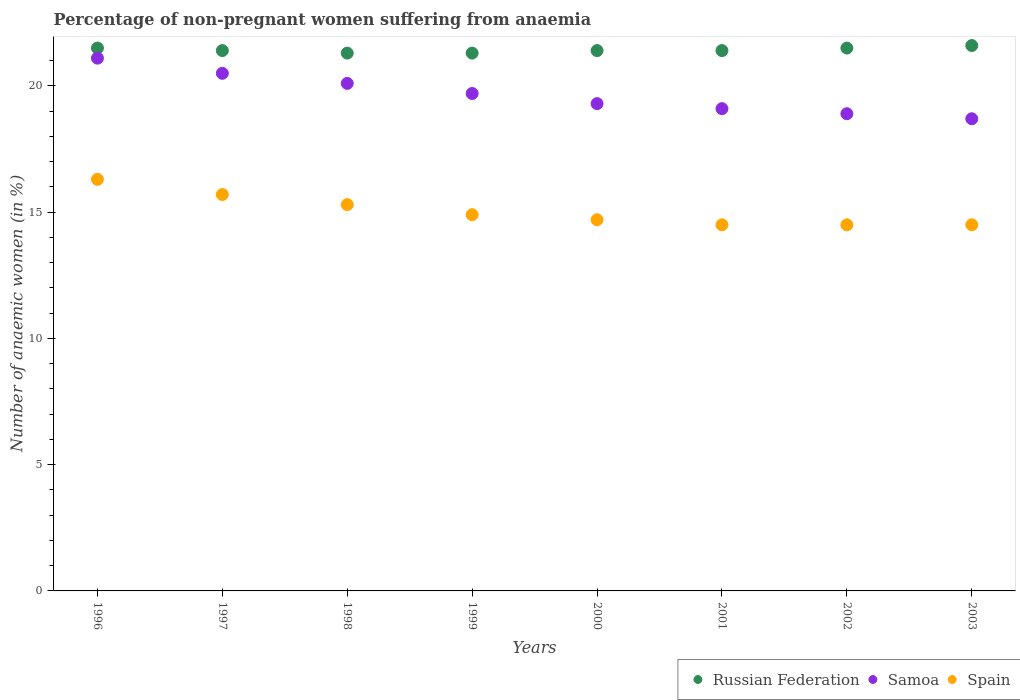How many different coloured dotlines are there?
Your answer should be compact. 3. Is the number of dotlines equal to the number of legend labels?
Offer a very short reply. Yes. What is the percentage of non-pregnant women suffering from anaemia in Spain in 1996?
Ensure brevity in your answer.  16.3. Across all years, what is the maximum percentage of non-pregnant women suffering from anaemia in Russian Federation?
Your answer should be compact. 21.6. Across all years, what is the minimum percentage of non-pregnant women suffering from anaemia in Samoa?
Provide a succinct answer. 18.7. In which year was the percentage of non-pregnant women suffering from anaemia in Russian Federation maximum?
Keep it short and to the point. 2003. What is the total percentage of non-pregnant women suffering from anaemia in Samoa in the graph?
Your response must be concise. 157.4. What is the difference between the percentage of non-pregnant women suffering from anaemia in Spain in 1997 and that in 1999?
Offer a very short reply. 0.8. What is the average percentage of non-pregnant women suffering from anaemia in Samoa per year?
Your answer should be very brief. 19.68. In the year 2003, what is the difference between the percentage of non-pregnant women suffering from anaemia in Samoa and percentage of non-pregnant women suffering from anaemia in Spain?
Keep it short and to the point. 4.2. What is the ratio of the percentage of non-pregnant women suffering from anaemia in Spain in 1999 to that in 2002?
Offer a terse response. 1.03. Is the percentage of non-pregnant women suffering from anaemia in Samoa in 1996 less than that in 2002?
Provide a short and direct response. No. Is the difference between the percentage of non-pregnant women suffering from anaemia in Samoa in 1998 and 2002 greater than the difference between the percentage of non-pregnant women suffering from anaemia in Spain in 1998 and 2002?
Keep it short and to the point. Yes. What is the difference between the highest and the second highest percentage of non-pregnant women suffering from anaemia in Spain?
Provide a succinct answer. 0.6. What is the difference between the highest and the lowest percentage of non-pregnant women suffering from anaemia in Spain?
Ensure brevity in your answer.  1.8. In how many years, is the percentage of non-pregnant women suffering from anaemia in Spain greater than the average percentage of non-pregnant women suffering from anaemia in Spain taken over all years?
Provide a short and direct response. 3. Is the sum of the percentage of non-pregnant women suffering from anaemia in Samoa in 2002 and 2003 greater than the maximum percentage of non-pregnant women suffering from anaemia in Spain across all years?
Make the answer very short. Yes. Does the percentage of non-pregnant women suffering from anaemia in Spain monotonically increase over the years?
Offer a terse response. No. Is the percentage of non-pregnant women suffering from anaemia in Spain strictly greater than the percentage of non-pregnant women suffering from anaemia in Russian Federation over the years?
Offer a very short reply. No. What is the difference between two consecutive major ticks on the Y-axis?
Make the answer very short. 5. Does the graph contain grids?
Your answer should be very brief. No. Where does the legend appear in the graph?
Offer a terse response. Bottom right. What is the title of the graph?
Ensure brevity in your answer.  Percentage of non-pregnant women suffering from anaemia. What is the label or title of the X-axis?
Offer a terse response. Years. What is the label or title of the Y-axis?
Offer a very short reply. Number of anaemic women (in %). What is the Number of anaemic women (in %) of Samoa in 1996?
Provide a short and direct response. 21.1. What is the Number of anaemic women (in %) of Russian Federation in 1997?
Your answer should be compact. 21.4. What is the Number of anaemic women (in %) of Samoa in 1997?
Provide a succinct answer. 20.5. What is the Number of anaemic women (in %) in Russian Federation in 1998?
Your response must be concise. 21.3. What is the Number of anaemic women (in %) in Samoa in 1998?
Ensure brevity in your answer.  20.1. What is the Number of anaemic women (in %) of Spain in 1998?
Your answer should be compact. 15.3. What is the Number of anaemic women (in %) in Russian Federation in 1999?
Give a very brief answer. 21.3. What is the Number of anaemic women (in %) of Russian Federation in 2000?
Your response must be concise. 21.4. What is the Number of anaemic women (in %) in Samoa in 2000?
Give a very brief answer. 19.3. What is the Number of anaemic women (in %) of Russian Federation in 2001?
Your answer should be compact. 21.4. What is the Number of anaemic women (in %) of Samoa in 2001?
Provide a succinct answer. 19.1. What is the Number of anaemic women (in %) in Russian Federation in 2002?
Your answer should be very brief. 21.5. What is the Number of anaemic women (in %) in Samoa in 2002?
Offer a terse response. 18.9. What is the Number of anaemic women (in %) in Spain in 2002?
Offer a very short reply. 14.5. What is the Number of anaemic women (in %) in Russian Federation in 2003?
Keep it short and to the point. 21.6. Across all years, what is the maximum Number of anaemic women (in %) in Russian Federation?
Offer a very short reply. 21.6. Across all years, what is the maximum Number of anaemic women (in %) of Samoa?
Give a very brief answer. 21.1. Across all years, what is the minimum Number of anaemic women (in %) in Russian Federation?
Provide a short and direct response. 21.3. What is the total Number of anaemic women (in %) in Russian Federation in the graph?
Give a very brief answer. 171.4. What is the total Number of anaemic women (in %) in Samoa in the graph?
Your response must be concise. 157.4. What is the total Number of anaemic women (in %) of Spain in the graph?
Provide a succinct answer. 120.4. What is the difference between the Number of anaemic women (in %) in Russian Federation in 1996 and that in 1998?
Provide a succinct answer. 0.2. What is the difference between the Number of anaemic women (in %) in Samoa in 1996 and that in 1998?
Your response must be concise. 1. What is the difference between the Number of anaemic women (in %) of Spain in 1996 and that in 1999?
Make the answer very short. 1.4. What is the difference between the Number of anaemic women (in %) of Russian Federation in 1996 and that in 2000?
Your response must be concise. 0.1. What is the difference between the Number of anaemic women (in %) of Samoa in 1996 and that in 2000?
Offer a terse response. 1.8. What is the difference between the Number of anaemic women (in %) of Spain in 1996 and that in 2000?
Ensure brevity in your answer.  1.6. What is the difference between the Number of anaemic women (in %) of Samoa in 1996 and that in 2002?
Make the answer very short. 2.2. What is the difference between the Number of anaemic women (in %) in Spain in 1997 and that in 1999?
Offer a very short reply. 0.8. What is the difference between the Number of anaemic women (in %) of Russian Federation in 1997 and that in 2000?
Your response must be concise. 0. What is the difference between the Number of anaemic women (in %) of Spain in 1997 and that in 2000?
Offer a terse response. 1. What is the difference between the Number of anaemic women (in %) of Russian Federation in 1997 and that in 2001?
Make the answer very short. 0. What is the difference between the Number of anaemic women (in %) of Samoa in 1997 and that in 2002?
Your answer should be very brief. 1.6. What is the difference between the Number of anaemic women (in %) in Spain in 1997 and that in 2002?
Your answer should be compact. 1.2. What is the difference between the Number of anaemic women (in %) in Russian Federation in 1997 and that in 2003?
Offer a very short reply. -0.2. What is the difference between the Number of anaemic women (in %) of Samoa in 1998 and that in 1999?
Ensure brevity in your answer.  0.4. What is the difference between the Number of anaemic women (in %) in Samoa in 1998 and that in 2000?
Ensure brevity in your answer.  0.8. What is the difference between the Number of anaemic women (in %) in Spain in 1998 and that in 2000?
Give a very brief answer. 0.6. What is the difference between the Number of anaemic women (in %) in Spain in 1998 and that in 2001?
Your answer should be compact. 0.8. What is the difference between the Number of anaemic women (in %) in Russian Federation in 1998 and that in 2002?
Provide a short and direct response. -0.2. What is the difference between the Number of anaemic women (in %) of Samoa in 1998 and that in 2002?
Your answer should be compact. 1.2. What is the difference between the Number of anaemic women (in %) of Russian Federation in 1998 and that in 2003?
Your answer should be very brief. -0.3. What is the difference between the Number of anaemic women (in %) in Samoa in 1998 and that in 2003?
Your answer should be very brief. 1.4. What is the difference between the Number of anaemic women (in %) of Spain in 1998 and that in 2003?
Provide a succinct answer. 0.8. What is the difference between the Number of anaemic women (in %) of Russian Federation in 1999 and that in 2000?
Your response must be concise. -0.1. What is the difference between the Number of anaemic women (in %) of Samoa in 1999 and that in 2000?
Offer a terse response. 0.4. What is the difference between the Number of anaemic women (in %) in Spain in 1999 and that in 2000?
Your answer should be very brief. 0.2. What is the difference between the Number of anaemic women (in %) in Russian Federation in 1999 and that in 2001?
Make the answer very short. -0.1. What is the difference between the Number of anaemic women (in %) in Samoa in 1999 and that in 2001?
Make the answer very short. 0.6. What is the difference between the Number of anaemic women (in %) in Spain in 1999 and that in 2001?
Offer a terse response. 0.4. What is the difference between the Number of anaemic women (in %) in Spain in 1999 and that in 2003?
Your answer should be compact. 0.4. What is the difference between the Number of anaemic women (in %) in Russian Federation in 2000 and that in 2001?
Offer a terse response. 0. What is the difference between the Number of anaemic women (in %) of Spain in 2000 and that in 2001?
Your answer should be compact. 0.2. What is the difference between the Number of anaemic women (in %) in Samoa in 2000 and that in 2003?
Provide a succinct answer. 0.6. What is the difference between the Number of anaemic women (in %) in Spain in 2001 and that in 2002?
Your response must be concise. 0. What is the difference between the Number of anaemic women (in %) in Russian Federation in 2002 and that in 2003?
Keep it short and to the point. -0.1. What is the difference between the Number of anaemic women (in %) in Samoa in 2002 and that in 2003?
Give a very brief answer. 0.2. What is the difference between the Number of anaemic women (in %) of Russian Federation in 1996 and the Number of anaemic women (in %) of Samoa in 1997?
Your response must be concise. 1. What is the difference between the Number of anaemic women (in %) of Russian Federation in 1996 and the Number of anaemic women (in %) of Spain in 1997?
Provide a succinct answer. 5.8. What is the difference between the Number of anaemic women (in %) in Russian Federation in 1996 and the Number of anaemic women (in %) in Spain in 1998?
Provide a succinct answer. 6.2. What is the difference between the Number of anaemic women (in %) in Samoa in 1996 and the Number of anaemic women (in %) in Spain in 1998?
Keep it short and to the point. 5.8. What is the difference between the Number of anaemic women (in %) in Russian Federation in 1996 and the Number of anaemic women (in %) in Samoa in 1999?
Your answer should be very brief. 1.8. What is the difference between the Number of anaemic women (in %) of Samoa in 1996 and the Number of anaemic women (in %) of Spain in 1999?
Ensure brevity in your answer.  6.2. What is the difference between the Number of anaemic women (in %) in Russian Federation in 1996 and the Number of anaemic women (in %) in Samoa in 2000?
Keep it short and to the point. 2.2. What is the difference between the Number of anaemic women (in %) in Russian Federation in 1996 and the Number of anaemic women (in %) in Spain in 2000?
Offer a terse response. 6.8. What is the difference between the Number of anaemic women (in %) in Russian Federation in 1996 and the Number of anaemic women (in %) in Samoa in 2001?
Ensure brevity in your answer.  2.4. What is the difference between the Number of anaemic women (in %) in Russian Federation in 1996 and the Number of anaemic women (in %) in Samoa in 2002?
Provide a short and direct response. 2.6. What is the difference between the Number of anaemic women (in %) of Russian Federation in 1996 and the Number of anaemic women (in %) of Spain in 2002?
Give a very brief answer. 7. What is the difference between the Number of anaemic women (in %) of Samoa in 1996 and the Number of anaemic women (in %) of Spain in 2003?
Provide a short and direct response. 6.6. What is the difference between the Number of anaemic women (in %) in Russian Federation in 1997 and the Number of anaemic women (in %) in Spain in 1998?
Provide a succinct answer. 6.1. What is the difference between the Number of anaemic women (in %) in Russian Federation in 1997 and the Number of anaemic women (in %) in Spain in 1999?
Provide a short and direct response. 6.5. What is the difference between the Number of anaemic women (in %) of Samoa in 1997 and the Number of anaemic women (in %) of Spain in 2000?
Your answer should be very brief. 5.8. What is the difference between the Number of anaemic women (in %) of Russian Federation in 1997 and the Number of anaemic women (in %) of Spain in 2001?
Keep it short and to the point. 6.9. What is the difference between the Number of anaemic women (in %) of Samoa in 1997 and the Number of anaemic women (in %) of Spain in 2003?
Offer a terse response. 6. What is the difference between the Number of anaemic women (in %) of Russian Federation in 1998 and the Number of anaemic women (in %) of Spain in 1999?
Offer a very short reply. 6.4. What is the difference between the Number of anaemic women (in %) of Samoa in 1998 and the Number of anaemic women (in %) of Spain in 1999?
Keep it short and to the point. 5.2. What is the difference between the Number of anaemic women (in %) in Russian Federation in 1998 and the Number of anaemic women (in %) in Spain in 2000?
Provide a succinct answer. 6.6. What is the difference between the Number of anaemic women (in %) in Russian Federation in 1998 and the Number of anaemic women (in %) in Spain in 2001?
Your answer should be compact. 6.8. What is the difference between the Number of anaemic women (in %) of Samoa in 1998 and the Number of anaemic women (in %) of Spain in 2002?
Keep it short and to the point. 5.6. What is the difference between the Number of anaemic women (in %) of Russian Federation in 1998 and the Number of anaemic women (in %) of Samoa in 2003?
Your response must be concise. 2.6. What is the difference between the Number of anaemic women (in %) in Russian Federation in 1999 and the Number of anaemic women (in %) in Samoa in 2000?
Provide a short and direct response. 2. What is the difference between the Number of anaemic women (in %) of Russian Federation in 1999 and the Number of anaemic women (in %) of Samoa in 2001?
Offer a very short reply. 2.2. What is the difference between the Number of anaemic women (in %) of Russian Federation in 1999 and the Number of anaemic women (in %) of Samoa in 2002?
Keep it short and to the point. 2.4. What is the difference between the Number of anaemic women (in %) of Samoa in 1999 and the Number of anaemic women (in %) of Spain in 2002?
Offer a terse response. 5.2. What is the difference between the Number of anaemic women (in %) of Russian Federation in 1999 and the Number of anaemic women (in %) of Samoa in 2003?
Keep it short and to the point. 2.6. What is the difference between the Number of anaemic women (in %) in Russian Federation in 1999 and the Number of anaemic women (in %) in Spain in 2003?
Your answer should be compact. 6.8. What is the difference between the Number of anaemic women (in %) in Russian Federation in 2000 and the Number of anaemic women (in %) in Samoa in 2001?
Your answer should be compact. 2.3. What is the difference between the Number of anaemic women (in %) of Samoa in 2000 and the Number of anaemic women (in %) of Spain in 2001?
Offer a very short reply. 4.8. What is the difference between the Number of anaemic women (in %) of Russian Federation in 2000 and the Number of anaemic women (in %) of Spain in 2002?
Your answer should be compact. 6.9. What is the difference between the Number of anaemic women (in %) in Russian Federation in 2000 and the Number of anaemic women (in %) in Spain in 2003?
Keep it short and to the point. 6.9. What is the difference between the Number of anaemic women (in %) of Russian Federation in 2001 and the Number of anaemic women (in %) of Spain in 2002?
Your answer should be very brief. 6.9. What is the difference between the Number of anaemic women (in %) in Samoa in 2001 and the Number of anaemic women (in %) in Spain in 2002?
Offer a very short reply. 4.6. What is the difference between the Number of anaemic women (in %) of Russian Federation in 2001 and the Number of anaemic women (in %) of Spain in 2003?
Give a very brief answer. 6.9. What is the difference between the Number of anaemic women (in %) of Russian Federation in 2002 and the Number of anaemic women (in %) of Spain in 2003?
Provide a succinct answer. 7. What is the average Number of anaemic women (in %) in Russian Federation per year?
Provide a succinct answer. 21.43. What is the average Number of anaemic women (in %) in Samoa per year?
Offer a terse response. 19.68. What is the average Number of anaemic women (in %) of Spain per year?
Your answer should be very brief. 15.05. In the year 1996, what is the difference between the Number of anaemic women (in %) of Russian Federation and Number of anaemic women (in %) of Samoa?
Provide a short and direct response. 0.4. In the year 1996, what is the difference between the Number of anaemic women (in %) of Russian Federation and Number of anaemic women (in %) of Spain?
Offer a terse response. 5.2. In the year 1997, what is the difference between the Number of anaemic women (in %) in Russian Federation and Number of anaemic women (in %) in Samoa?
Ensure brevity in your answer.  0.9. In the year 1998, what is the difference between the Number of anaemic women (in %) of Russian Federation and Number of anaemic women (in %) of Spain?
Your answer should be compact. 6. In the year 2001, what is the difference between the Number of anaemic women (in %) in Russian Federation and Number of anaemic women (in %) in Spain?
Provide a succinct answer. 6.9. In the year 2002, what is the difference between the Number of anaemic women (in %) of Russian Federation and Number of anaemic women (in %) of Samoa?
Your answer should be very brief. 2.6. What is the ratio of the Number of anaemic women (in %) in Samoa in 1996 to that in 1997?
Offer a very short reply. 1.03. What is the ratio of the Number of anaemic women (in %) of Spain in 1996 to that in 1997?
Provide a succinct answer. 1.04. What is the ratio of the Number of anaemic women (in %) in Russian Federation in 1996 to that in 1998?
Ensure brevity in your answer.  1.01. What is the ratio of the Number of anaemic women (in %) in Samoa in 1996 to that in 1998?
Your answer should be compact. 1.05. What is the ratio of the Number of anaemic women (in %) in Spain in 1996 to that in 1998?
Your response must be concise. 1.07. What is the ratio of the Number of anaemic women (in %) of Russian Federation in 1996 to that in 1999?
Keep it short and to the point. 1.01. What is the ratio of the Number of anaemic women (in %) of Samoa in 1996 to that in 1999?
Make the answer very short. 1.07. What is the ratio of the Number of anaemic women (in %) in Spain in 1996 to that in 1999?
Offer a very short reply. 1.09. What is the ratio of the Number of anaemic women (in %) of Russian Federation in 1996 to that in 2000?
Provide a short and direct response. 1. What is the ratio of the Number of anaemic women (in %) in Samoa in 1996 to that in 2000?
Keep it short and to the point. 1.09. What is the ratio of the Number of anaemic women (in %) of Spain in 1996 to that in 2000?
Ensure brevity in your answer.  1.11. What is the ratio of the Number of anaemic women (in %) in Russian Federation in 1996 to that in 2001?
Offer a terse response. 1. What is the ratio of the Number of anaemic women (in %) in Samoa in 1996 to that in 2001?
Your answer should be very brief. 1.1. What is the ratio of the Number of anaemic women (in %) in Spain in 1996 to that in 2001?
Your answer should be very brief. 1.12. What is the ratio of the Number of anaemic women (in %) in Samoa in 1996 to that in 2002?
Provide a succinct answer. 1.12. What is the ratio of the Number of anaemic women (in %) in Spain in 1996 to that in 2002?
Your response must be concise. 1.12. What is the ratio of the Number of anaemic women (in %) in Samoa in 1996 to that in 2003?
Offer a very short reply. 1.13. What is the ratio of the Number of anaemic women (in %) of Spain in 1996 to that in 2003?
Offer a terse response. 1.12. What is the ratio of the Number of anaemic women (in %) of Russian Federation in 1997 to that in 1998?
Provide a short and direct response. 1. What is the ratio of the Number of anaemic women (in %) in Samoa in 1997 to that in 1998?
Give a very brief answer. 1.02. What is the ratio of the Number of anaemic women (in %) in Spain in 1997 to that in 1998?
Your answer should be very brief. 1.03. What is the ratio of the Number of anaemic women (in %) of Russian Federation in 1997 to that in 1999?
Ensure brevity in your answer.  1. What is the ratio of the Number of anaemic women (in %) of Samoa in 1997 to that in 1999?
Ensure brevity in your answer.  1.04. What is the ratio of the Number of anaemic women (in %) of Spain in 1997 to that in 1999?
Your answer should be very brief. 1.05. What is the ratio of the Number of anaemic women (in %) of Russian Federation in 1997 to that in 2000?
Offer a very short reply. 1. What is the ratio of the Number of anaemic women (in %) in Samoa in 1997 to that in 2000?
Provide a short and direct response. 1.06. What is the ratio of the Number of anaemic women (in %) of Spain in 1997 to that in 2000?
Your answer should be compact. 1.07. What is the ratio of the Number of anaemic women (in %) in Russian Federation in 1997 to that in 2001?
Provide a short and direct response. 1. What is the ratio of the Number of anaemic women (in %) in Samoa in 1997 to that in 2001?
Keep it short and to the point. 1.07. What is the ratio of the Number of anaemic women (in %) in Spain in 1997 to that in 2001?
Make the answer very short. 1.08. What is the ratio of the Number of anaemic women (in %) in Russian Federation in 1997 to that in 2002?
Your response must be concise. 1. What is the ratio of the Number of anaemic women (in %) of Samoa in 1997 to that in 2002?
Provide a succinct answer. 1.08. What is the ratio of the Number of anaemic women (in %) in Spain in 1997 to that in 2002?
Keep it short and to the point. 1.08. What is the ratio of the Number of anaemic women (in %) of Russian Federation in 1997 to that in 2003?
Your answer should be very brief. 0.99. What is the ratio of the Number of anaemic women (in %) of Samoa in 1997 to that in 2003?
Offer a very short reply. 1.1. What is the ratio of the Number of anaemic women (in %) of Spain in 1997 to that in 2003?
Offer a very short reply. 1.08. What is the ratio of the Number of anaemic women (in %) in Russian Federation in 1998 to that in 1999?
Your answer should be compact. 1. What is the ratio of the Number of anaemic women (in %) in Samoa in 1998 to that in 1999?
Your response must be concise. 1.02. What is the ratio of the Number of anaemic women (in %) in Spain in 1998 to that in 1999?
Offer a terse response. 1.03. What is the ratio of the Number of anaemic women (in %) of Russian Federation in 1998 to that in 2000?
Keep it short and to the point. 1. What is the ratio of the Number of anaemic women (in %) of Samoa in 1998 to that in 2000?
Give a very brief answer. 1.04. What is the ratio of the Number of anaemic women (in %) in Spain in 1998 to that in 2000?
Make the answer very short. 1.04. What is the ratio of the Number of anaemic women (in %) in Russian Federation in 1998 to that in 2001?
Ensure brevity in your answer.  1. What is the ratio of the Number of anaemic women (in %) of Samoa in 1998 to that in 2001?
Your response must be concise. 1.05. What is the ratio of the Number of anaemic women (in %) of Spain in 1998 to that in 2001?
Offer a terse response. 1.06. What is the ratio of the Number of anaemic women (in %) of Russian Federation in 1998 to that in 2002?
Offer a terse response. 0.99. What is the ratio of the Number of anaemic women (in %) of Samoa in 1998 to that in 2002?
Keep it short and to the point. 1.06. What is the ratio of the Number of anaemic women (in %) in Spain in 1998 to that in 2002?
Keep it short and to the point. 1.06. What is the ratio of the Number of anaemic women (in %) of Russian Federation in 1998 to that in 2003?
Make the answer very short. 0.99. What is the ratio of the Number of anaemic women (in %) of Samoa in 1998 to that in 2003?
Make the answer very short. 1.07. What is the ratio of the Number of anaemic women (in %) of Spain in 1998 to that in 2003?
Your answer should be compact. 1.06. What is the ratio of the Number of anaemic women (in %) of Samoa in 1999 to that in 2000?
Make the answer very short. 1.02. What is the ratio of the Number of anaemic women (in %) of Spain in 1999 to that in 2000?
Offer a terse response. 1.01. What is the ratio of the Number of anaemic women (in %) in Russian Federation in 1999 to that in 2001?
Keep it short and to the point. 1. What is the ratio of the Number of anaemic women (in %) of Samoa in 1999 to that in 2001?
Provide a succinct answer. 1.03. What is the ratio of the Number of anaemic women (in %) of Spain in 1999 to that in 2001?
Your answer should be compact. 1.03. What is the ratio of the Number of anaemic women (in %) of Samoa in 1999 to that in 2002?
Provide a short and direct response. 1.04. What is the ratio of the Number of anaemic women (in %) in Spain in 1999 to that in 2002?
Ensure brevity in your answer.  1.03. What is the ratio of the Number of anaemic women (in %) in Russian Federation in 1999 to that in 2003?
Your answer should be very brief. 0.99. What is the ratio of the Number of anaemic women (in %) of Samoa in 1999 to that in 2003?
Provide a succinct answer. 1.05. What is the ratio of the Number of anaemic women (in %) of Spain in 1999 to that in 2003?
Ensure brevity in your answer.  1.03. What is the ratio of the Number of anaemic women (in %) in Samoa in 2000 to that in 2001?
Offer a terse response. 1.01. What is the ratio of the Number of anaemic women (in %) of Spain in 2000 to that in 2001?
Provide a short and direct response. 1.01. What is the ratio of the Number of anaemic women (in %) in Samoa in 2000 to that in 2002?
Offer a terse response. 1.02. What is the ratio of the Number of anaemic women (in %) in Spain in 2000 to that in 2002?
Provide a short and direct response. 1.01. What is the ratio of the Number of anaemic women (in %) of Samoa in 2000 to that in 2003?
Ensure brevity in your answer.  1.03. What is the ratio of the Number of anaemic women (in %) in Spain in 2000 to that in 2003?
Offer a very short reply. 1.01. What is the ratio of the Number of anaemic women (in %) of Russian Federation in 2001 to that in 2002?
Ensure brevity in your answer.  1. What is the ratio of the Number of anaemic women (in %) in Samoa in 2001 to that in 2002?
Offer a terse response. 1.01. What is the ratio of the Number of anaemic women (in %) in Russian Federation in 2001 to that in 2003?
Ensure brevity in your answer.  0.99. What is the ratio of the Number of anaemic women (in %) in Samoa in 2001 to that in 2003?
Offer a terse response. 1.02. What is the ratio of the Number of anaemic women (in %) of Spain in 2001 to that in 2003?
Offer a terse response. 1. What is the ratio of the Number of anaemic women (in %) in Russian Federation in 2002 to that in 2003?
Your answer should be compact. 1. What is the ratio of the Number of anaemic women (in %) of Samoa in 2002 to that in 2003?
Offer a very short reply. 1.01. What is the difference between the highest and the second highest Number of anaemic women (in %) of Russian Federation?
Your answer should be compact. 0.1. What is the difference between the highest and the second highest Number of anaemic women (in %) of Samoa?
Your answer should be very brief. 0.6. What is the difference between the highest and the lowest Number of anaemic women (in %) in Samoa?
Keep it short and to the point. 2.4. 